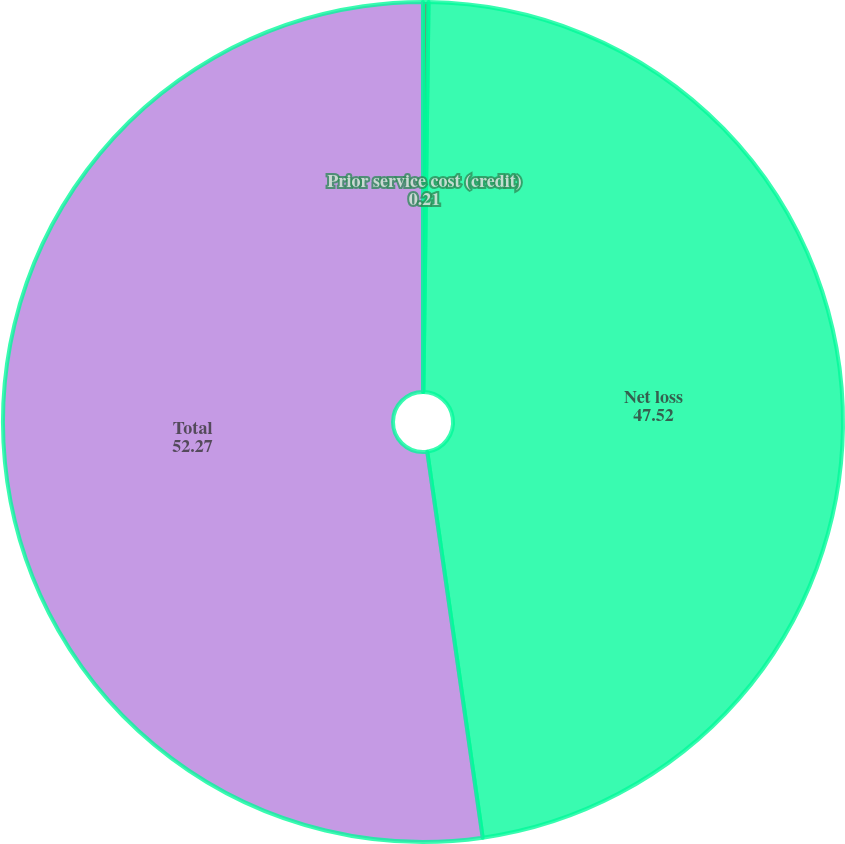Convert chart. <chart><loc_0><loc_0><loc_500><loc_500><pie_chart><fcel>Prior service cost (credit)<fcel>Net loss<fcel>Total<nl><fcel>0.21%<fcel>47.52%<fcel>52.27%<nl></chart> 